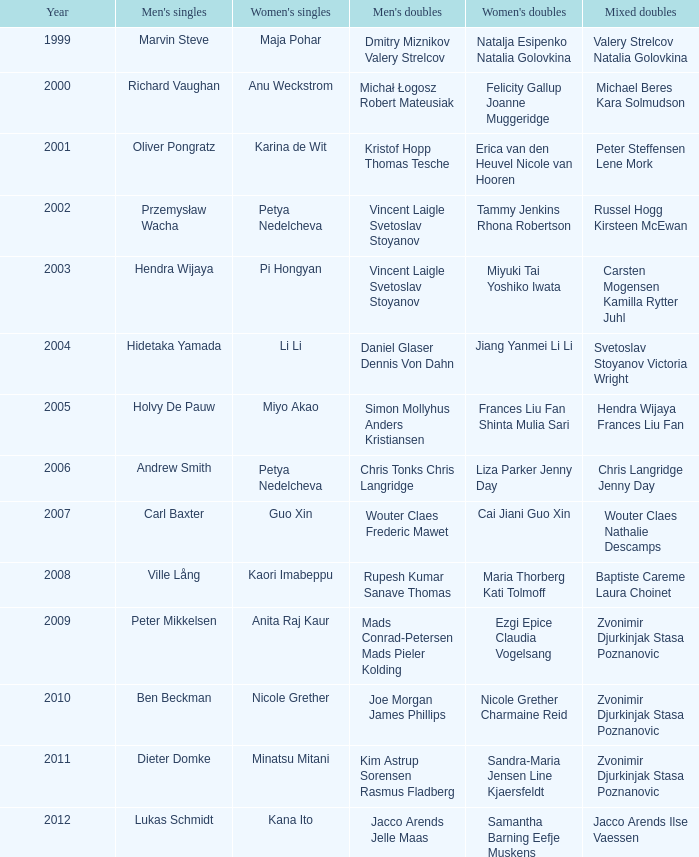What's the first year that Guo Xin featured in women's singles? 2007.0. 